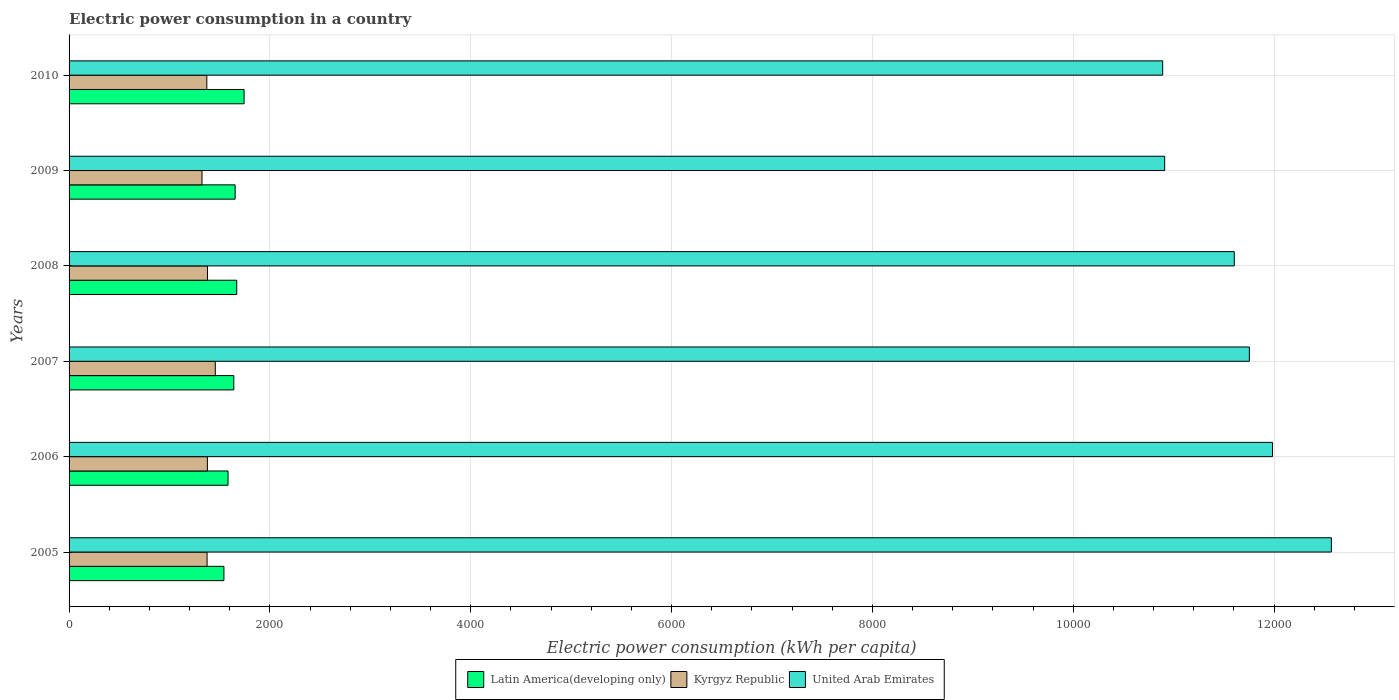How many different coloured bars are there?
Offer a very short reply. 3. How many groups of bars are there?
Ensure brevity in your answer.  6. Are the number of bars per tick equal to the number of legend labels?
Provide a short and direct response. Yes. Are the number of bars on each tick of the Y-axis equal?
Give a very brief answer. Yes. How many bars are there on the 2nd tick from the bottom?
Ensure brevity in your answer.  3. In how many cases, is the number of bars for a given year not equal to the number of legend labels?
Provide a short and direct response. 0. What is the electric power consumption in in Latin America(developing only) in 2009?
Keep it short and to the point. 1654.08. Across all years, what is the maximum electric power consumption in in United Arab Emirates?
Offer a terse response. 1.26e+04. Across all years, what is the minimum electric power consumption in in Latin America(developing only)?
Your answer should be compact. 1542.13. In which year was the electric power consumption in in United Arab Emirates maximum?
Your response must be concise. 2005. In which year was the electric power consumption in in Latin America(developing only) minimum?
Offer a terse response. 2005. What is the total electric power consumption in in United Arab Emirates in the graph?
Give a very brief answer. 6.97e+04. What is the difference between the electric power consumption in in United Arab Emirates in 2007 and that in 2009?
Your answer should be compact. 843.49. What is the difference between the electric power consumption in in United Arab Emirates in 2005 and the electric power consumption in in Latin America(developing only) in 2009?
Your answer should be very brief. 1.09e+04. What is the average electric power consumption in in Latin America(developing only) per year?
Your answer should be very brief. 1638.79. In the year 2009, what is the difference between the electric power consumption in in Latin America(developing only) and electric power consumption in in Kyrgyz Republic?
Your answer should be compact. 330.35. What is the ratio of the electric power consumption in in Kyrgyz Republic in 2007 to that in 2010?
Your response must be concise. 1.06. What is the difference between the highest and the second highest electric power consumption in in Latin America(developing only)?
Provide a short and direct response. 73.18. What is the difference between the highest and the lowest electric power consumption in in Latin America(developing only)?
Your answer should be compact. 200.81. Is the sum of the electric power consumption in in United Arab Emirates in 2008 and 2010 greater than the maximum electric power consumption in in Latin America(developing only) across all years?
Give a very brief answer. Yes. What does the 2nd bar from the top in 2007 represents?
Your answer should be compact. Kyrgyz Republic. What does the 3rd bar from the bottom in 2010 represents?
Give a very brief answer. United Arab Emirates. Is it the case that in every year, the sum of the electric power consumption in in United Arab Emirates and electric power consumption in in Latin America(developing only) is greater than the electric power consumption in in Kyrgyz Republic?
Your response must be concise. Yes. How many years are there in the graph?
Your response must be concise. 6. Are the values on the major ticks of X-axis written in scientific E-notation?
Ensure brevity in your answer.  No. Does the graph contain any zero values?
Your response must be concise. No. What is the title of the graph?
Make the answer very short. Electric power consumption in a country. What is the label or title of the X-axis?
Provide a short and direct response. Electric power consumption (kWh per capita). What is the label or title of the Y-axis?
Give a very brief answer. Years. What is the Electric power consumption (kWh per capita) in Latin America(developing only) in 2005?
Give a very brief answer. 1542.13. What is the Electric power consumption (kWh per capita) of Kyrgyz Republic in 2005?
Your answer should be compact. 1374.31. What is the Electric power consumption (kWh per capita) in United Arab Emirates in 2005?
Your answer should be very brief. 1.26e+04. What is the Electric power consumption (kWh per capita) in Latin America(developing only) in 2006?
Make the answer very short. 1583.23. What is the Electric power consumption (kWh per capita) in Kyrgyz Republic in 2006?
Your answer should be very brief. 1377.43. What is the Electric power consumption (kWh per capita) in United Arab Emirates in 2006?
Offer a terse response. 1.20e+04. What is the Electric power consumption (kWh per capita) of Latin America(developing only) in 2007?
Your answer should be compact. 1640.63. What is the Electric power consumption (kWh per capita) in Kyrgyz Republic in 2007?
Your answer should be very brief. 1456.23. What is the Electric power consumption (kWh per capita) in United Arab Emirates in 2007?
Make the answer very short. 1.18e+04. What is the Electric power consumption (kWh per capita) of Latin America(developing only) in 2008?
Give a very brief answer. 1669.76. What is the Electric power consumption (kWh per capita) of Kyrgyz Republic in 2008?
Ensure brevity in your answer.  1378.72. What is the Electric power consumption (kWh per capita) of United Arab Emirates in 2008?
Ensure brevity in your answer.  1.16e+04. What is the Electric power consumption (kWh per capita) of Latin America(developing only) in 2009?
Provide a short and direct response. 1654.08. What is the Electric power consumption (kWh per capita) of Kyrgyz Republic in 2009?
Make the answer very short. 1323.72. What is the Electric power consumption (kWh per capita) in United Arab Emirates in 2009?
Ensure brevity in your answer.  1.09e+04. What is the Electric power consumption (kWh per capita) of Latin America(developing only) in 2010?
Offer a terse response. 1742.94. What is the Electric power consumption (kWh per capita) in Kyrgyz Republic in 2010?
Your response must be concise. 1371.72. What is the Electric power consumption (kWh per capita) of United Arab Emirates in 2010?
Keep it short and to the point. 1.09e+04. Across all years, what is the maximum Electric power consumption (kWh per capita) in Latin America(developing only)?
Give a very brief answer. 1742.94. Across all years, what is the maximum Electric power consumption (kWh per capita) in Kyrgyz Republic?
Make the answer very short. 1456.23. Across all years, what is the maximum Electric power consumption (kWh per capita) of United Arab Emirates?
Ensure brevity in your answer.  1.26e+04. Across all years, what is the minimum Electric power consumption (kWh per capita) in Latin America(developing only)?
Ensure brevity in your answer.  1542.13. Across all years, what is the minimum Electric power consumption (kWh per capita) of Kyrgyz Republic?
Give a very brief answer. 1323.72. Across all years, what is the minimum Electric power consumption (kWh per capita) in United Arab Emirates?
Ensure brevity in your answer.  1.09e+04. What is the total Electric power consumption (kWh per capita) of Latin America(developing only) in the graph?
Your answer should be compact. 9832.77. What is the total Electric power consumption (kWh per capita) in Kyrgyz Republic in the graph?
Your response must be concise. 8282.14. What is the total Electric power consumption (kWh per capita) of United Arab Emirates in the graph?
Keep it short and to the point. 6.97e+04. What is the difference between the Electric power consumption (kWh per capita) of Latin America(developing only) in 2005 and that in 2006?
Offer a very short reply. -41.1. What is the difference between the Electric power consumption (kWh per capita) of Kyrgyz Republic in 2005 and that in 2006?
Offer a terse response. -3.13. What is the difference between the Electric power consumption (kWh per capita) of United Arab Emirates in 2005 and that in 2006?
Your answer should be very brief. 586.11. What is the difference between the Electric power consumption (kWh per capita) of Latin America(developing only) in 2005 and that in 2007?
Make the answer very short. -98.51. What is the difference between the Electric power consumption (kWh per capita) of Kyrgyz Republic in 2005 and that in 2007?
Make the answer very short. -81.92. What is the difference between the Electric power consumption (kWh per capita) of United Arab Emirates in 2005 and that in 2007?
Your response must be concise. 816.64. What is the difference between the Electric power consumption (kWh per capita) in Latin America(developing only) in 2005 and that in 2008?
Your answer should be compact. -127.63. What is the difference between the Electric power consumption (kWh per capita) of Kyrgyz Republic in 2005 and that in 2008?
Provide a succinct answer. -4.41. What is the difference between the Electric power consumption (kWh per capita) of United Arab Emirates in 2005 and that in 2008?
Make the answer very short. 966.91. What is the difference between the Electric power consumption (kWh per capita) of Latin America(developing only) in 2005 and that in 2009?
Your answer should be very brief. -111.95. What is the difference between the Electric power consumption (kWh per capita) of Kyrgyz Republic in 2005 and that in 2009?
Offer a terse response. 50.58. What is the difference between the Electric power consumption (kWh per capita) of United Arab Emirates in 2005 and that in 2009?
Keep it short and to the point. 1660.13. What is the difference between the Electric power consumption (kWh per capita) of Latin America(developing only) in 2005 and that in 2010?
Provide a short and direct response. -200.81. What is the difference between the Electric power consumption (kWh per capita) in Kyrgyz Republic in 2005 and that in 2010?
Provide a succinct answer. 2.59. What is the difference between the Electric power consumption (kWh per capita) of United Arab Emirates in 2005 and that in 2010?
Offer a terse response. 1680.15. What is the difference between the Electric power consumption (kWh per capita) of Latin America(developing only) in 2006 and that in 2007?
Your answer should be compact. -57.41. What is the difference between the Electric power consumption (kWh per capita) of Kyrgyz Republic in 2006 and that in 2007?
Your response must be concise. -78.8. What is the difference between the Electric power consumption (kWh per capita) of United Arab Emirates in 2006 and that in 2007?
Provide a succinct answer. 230.52. What is the difference between the Electric power consumption (kWh per capita) of Latin America(developing only) in 2006 and that in 2008?
Offer a very short reply. -86.53. What is the difference between the Electric power consumption (kWh per capita) in Kyrgyz Republic in 2006 and that in 2008?
Keep it short and to the point. -1.29. What is the difference between the Electric power consumption (kWh per capita) in United Arab Emirates in 2006 and that in 2008?
Ensure brevity in your answer.  380.8. What is the difference between the Electric power consumption (kWh per capita) of Latin America(developing only) in 2006 and that in 2009?
Give a very brief answer. -70.85. What is the difference between the Electric power consumption (kWh per capita) in Kyrgyz Republic in 2006 and that in 2009?
Provide a succinct answer. 53.71. What is the difference between the Electric power consumption (kWh per capita) of United Arab Emirates in 2006 and that in 2009?
Offer a very short reply. 1074.02. What is the difference between the Electric power consumption (kWh per capita) of Latin America(developing only) in 2006 and that in 2010?
Provide a short and direct response. -159.72. What is the difference between the Electric power consumption (kWh per capita) in Kyrgyz Republic in 2006 and that in 2010?
Provide a succinct answer. 5.71. What is the difference between the Electric power consumption (kWh per capita) in United Arab Emirates in 2006 and that in 2010?
Provide a succinct answer. 1094.03. What is the difference between the Electric power consumption (kWh per capita) in Latin America(developing only) in 2007 and that in 2008?
Provide a short and direct response. -29.12. What is the difference between the Electric power consumption (kWh per capita) of Kyrgyz Republic in 2007 and that in 2008?
Offer a terse response. 77.51. What is the difference between the Electric power consumption (kWh per capita) in United Arab Emirates in 2007 and that in 2008?
Offer a terse response. 150.27. What is the difference between the Electric power consumption (kWh per capita) in Latin America(developing only) in 2007 and that in 2009?
Offer a very short reply. -13.44. What is the difference between the Electric power consumption (kWh per capita) of Kyrgyz Republic in 2007 and that in 2009?
Keep it short and to the point. 132.51. What is the difference between the Electric power consumption (kWh per capita) of United Arab Emirates in 2007 and that in 2009?
Offer a very short reply. 843.49. What is the difference between the Electric power consumption (kWh per capita) of Latin America(developing only) in 2007 and that in 2010?
Keep it short and to the point. -102.31. What is the difference between the Electric power consumption (kWh per capita) of Kyrgyz Republic in 2007 and that in 2010?
Your answer should be very brief. 84.51. What is the difference between the Electric power consumption (kWh per capita) in United Arab Emirates in 2007 and that in 2010?
Ensure brevity in your answer.  863.51. What is the difference between the Electric power consumption (kWh per capita) in Latin America(developing only) in 2008 and that in 2009?
Keep it short and to the point. 15.68. What is the difference between the Electric power consumption (kWh per capita) in Kyrgyz Republic in 2008 and that in 2009?
Provide a short and direct response. 55. What is the difference between the Electric power consumption (kWh per capita) in United Arab Emirates in 2008 and that in 2009?
Provide a succinct answer. 693.22. What is the difference between the Electric power consumption (kWh per capita) of Latin America(developing only) in 2008 and that in 2010?
Provide a short and direct response. -73.18. What is the difference between the Electric power consumption (kWh per capita) in Kyrgyz Republic in 2008 and that in 2010?
Offer a terse response. 7. What is the difference between the Electric power consumption (kWh per capita) of United Arab Emirates in 2008 and that in 2010?
Your response must be concise. 713.24. What is the difference between the Electric power consumption (kWh per capita) of Latin America(developing only) in 2009 and that in 2010?
Keep it short and to the point. -88.87. What is the difference between the Electric power consumption (kWh per capita) of Kyrgyz Republic in 2009 and that in 2010?
Provide a succinct answer. -48. What is the difference between the Electric power consumption (kWh per capita) in United Arab Emirates in 2009 and that in 2010?
Give a very brief answer. 20.02. What is the difference between the Electric power consumption (kWh per capita) in Latin America(developing only) in 2005 and the Electric power consumption (kWh per capita) in Kyrgyz Republic in 2006?
Your answer should be very brief. 164.7. What is the difference between the Electric power consumption (kWh per capita) of Latin America(developing only) in 2005 and the Electric power consumption (kWh per capita) of United Arab Emirates in 2006?
Ensure brevity in your answer.  -1.04e+04. What is the difference between the Electric power consumption (kWh per capita) of Kyrgyz Republic in 2005 and the Electric power consumption (kWh per capita) of United Arab Emirates in 2006?
Your answer should be very brief. -1.06e+04. What is the difference between the Electric power consumption (kWh per capita) of Latin America(developing only) in 2005 and the Electric power consumption (kWh per capita) of Kyrgyz Republic in 2007?
Your answer should be compact. 85.9. What is the difference between the Electric power consumption (kWh per capita) of Latin America(developing only) in 2005 and the Electric power consumption (kWh per capita) of United Arab Emirates in 2007?
Offer a terse response. -1.02e+04. What is the difference between the Electric power consumption (kWh per capita) of Kyrgyz Republic in 2005 and the Electric power consumption (kWh per capita) of United Arab Emirates in 2007?
Your answer should be very brief. -1.04e+04. What is the difference between the Electric power consumption (kWh per capita) of Latin America(developing only) in 2005 and the Electric power consumption (kWh per capita) of Kyrgyz Republic in 2008?
Offer a terse response. 163.41. What is the difference between the Electric power consumption (kWh per capita) in Latin America(developing only) in 2005 and the Electric power consumption (kWh per capita) in United Arab Emirates in 2008?
Your response must be concise. -1.01e+04. What is the difference between the Electric power consumption (kWh per capita) of Kyrgyz Republic in 2005 and the Electric power consumption (kWh per capita) of United Arab Emirates in 2008?
Provide a succinct answer. -1.02e+04. What is the difference between the Electric power consumption (kWh per capita) in Latin America(developing only) in 2005 and the Electric power consumption (kWh per capita) in Kyrgyz Republic in 2009?
Keep it short and to the point. 218.41. What is the difference between the Electric power consumption (kWh per capita) in Latin America(developing only) in 2005 and the Electric power consumption (kWh per capita) in United Arab Emirates in 2009?
Offer a very short reply. -9368.76. What is the difference between the Electric power consumption (kWh per capita) in Kyrgyz Republic in 2005 and the Electric power consumption (kWh per capita) in United Arab Emirates in 2009?
Your answer should be compact. -9536.58. What is the difference between the Electric power consumption (kWh per capita) of Latin America(developing only) in 2005 and the Electric power consumption (kWh per capita) of Kyrgyz Republic in 2010?
Provide a succinct answer. 170.41. What is the difference between the Electric power consumption (kWh per capita) of Latin America(developing only) in 2005 and the Electric power consumption (kWh per capita) of United Arab Emirates in 2010?
Keep it short and to the point. -9348.74. What is the difference between the Electric power consumption (kWh per capita) in Kyrgyz Republic in 2005 and the Electric power consumption (kWh per capita) in United Arab Emirates in 2010?
Your answer should be compact. -9516.56. What is the difference between the Electric power consumption (kWh per capita) in Latin America(developing only) in 2006 and the Electric power consumption (kWh per capita) in Kyrgyz Republic in 2007?
Your answer should be compact. 127. What is the difference between the Electric power consumption (kWh per capita) of Latin America(developing only) in 2006 and the Electric power consumption (kWh per capita) of United Arab Emirates in 2007?
Give a very brief answer. -1.02e+04. What is the difference between the Electric power consumption (kWh per capita) of Kyrgyz Republic in 2006 and the Electric power consumption (kWh per capita) of United Arab Emirates in 2007?
Make the answer very short. -1.04e+04. What is the difference between the Electric power consumption (kWh per capita) in Latin America(developing only) in 2006 and the Electric power consumption (kWh per capita) in Kyrgyz Republic in 2008?
Keep it short and to the point. 204.51. What is the difference between the Electric power consumption (kWh per capita) in Latin America(developing only) in 2006 and the Electric power consumption (kWh per capita) in United Arab Emirates in 2008?
Offer a terse response. -1.00e+04. What is the difference between the Electric power consumption (kWh per capita) of Kyrgyz Republic in 2006 and the Electric power consumption (kWh per capita) of United Arab Emirates in 2008?
Make the answer very short. -1.02e+04. What is the difference between the Electric power consumption (kWh per capita) in Latin America(developing only) in 2006 and the Electric power consumption (kWh per capita) in Kyrgyz Republic in 2009?
Provide a succinct answer. 259.5. What is the difference between the Electric power consumption (kWh per capita) of Latin America(developing only) in 2006 and the Electric power consumption (kWh per capita) of United Arab Emirates in 2009?
Provide a short and direct response. -9327.66. What is the difference between the Electric power consumption (kWh per capita) in Kyrgyz Republic in 2006 and the Electric power consumption (kWh per capita) in United Arab Emirates in 2009?
Make the answer very short. -9533.45. What is the difference between the Electric power consumption (kWh per capita) in Latin America(developing only) in 2006 and the Electric power consumption (kWh per capita) in Kyrgyz Republic in 2010?
Your response must be concise. 211.51. What is the difference between the Electric power consumption (kWh per capita) of Latin America(developing only) in 2006 and the Electric power consumption (kWh per capita) of United Arab Emirates in 2010?
Make the answer very short. -9307.65. What is the difference between the Electric power consumption (kWh per capita) in Kyrgyz Republic in 2006 and the Electric power consumption (kWh per capita) in United Arab Emirates in 2010?
Make the answer very short. -9513.44. What is the difference between the Electric power consumption (kWh per capita) of Latin America(developing only) in 2007 and the Electric power consumption (kWh per capita) of Kyrgyz Republic in 2008?
Ensure brevity in your answer.  261.91. What is the difference between the Electric power consumption (kWh per capita) in Latin America(developing only) in 2007 and the Electric power consumption (kWh per capita) in United Arab Emirates in 2008?
Offer a very short reply. -9963.47. What is the difference between the Electric power consumption (kWh per capita) of Kyrgyz Republic in 2007 and the Electric power consumption (kWh per capita) of United Arab Emirates in 2008?
Ensure brevity in your answer.  -1.01e+04. What is the difference between the Electric power consumption (kWh per capita) of Latin America(developing only) in 2007 and the Electric power consumption (kWh per capita) of Kyrgyz Republic in 2009?
Provide a short and direct response. 316.91. What is the difference between the Electric power consumption (kWh per capita) in Latin America(developing only) in 2007 and the Electric power consumption (kWh per capita) in United Arab Emirates in 2009?
Offer a terse response. -9270.25. What is the difference between the Electric power consumption (kWh per capita) in Kyrgyz Republic in 2007 and the Electric power consumption (kWh per capita) in United Arab Emirates in 2009?
Ensure brevity in your answer.  -9454.66. What is the difference between the Electric power consumption (kWh per capita) in Latin America(developing only) in 2007 and the Electric power consumption (kWh per capita) in Kyrgyz Republic in 2010?
Keep it short and to the point. 268.91. What is the difference between the Electric power consumption (kWh per capita) of Latin America(developing only) in 2007 and the Electric power consumption (kWh per capita) of United Arab Emirates in 2010?
Make the answer very short. -9250.24. What is the difference between the Electric power consumption (kWh per capita) in Kyrgyz Republic in 2007 and the Electric power consumption (kWh per capita) in United Arab Emirates in 2010?
Your response must be concise. -9434.64. What is the difference between the Electric power consumption (kWh per capita) of Latin America(developing only) in 2008 and the Electric power consumption (kWh per capita) of Kyrgyz Republic in 2009?
Keep it short and to the point. 346.04. What is the difference between the Electric power consumption (kWh per capita) in Latin America(developing only) in 2008 and the Electric power consumption (kWh per capita) in United Arab Emirates in 2009?
Ensure brevity in your answer.  -9241.13. What is the difference between the Electric power consumption (kWh per capita) in Kyrgyz Republic in 2008 and the Electric power consumption (kWh per capita) in United Arab Emirates in 2009?
Make the answer very short. -9532.17. What is the difference between the Electric power consumption (kWh per capita) of Latin America(developing only) in 2008 and the Electric power consumption (kWh per capita) of Kyrgyz Republic in 2010?
Offer a terse response. 298.04. What is the difference between the Electric power consumption (kWh per capita) in Latin America(developing only) in 2008 and the Electric power consumption (kWh per capita) in United Arab Emirates in 2010?
Make the answer very short. -9221.11. What is the difference between the Electric power consumption (kWh per capita) in Kyrgyz Republic in 2008 and the Electric power consumption (kWh per capita) in United Arab Emirates in 2010?
Give a very brief answer. -9512.15. What is the difference between the Electric power consumption (kWh per capita) in Latin America(developing only) in 2009 and the Electric power consumption (kWh per capita) in Kyrgyz Republic in 2010?
Give a very brief answer. 282.35. What is the difference between the Electric power consumption (kWh per capita) in Latin America(developing only) in 2009 and the Electric power consumption (kWh per capita) in United Arab Emirates in 2010?
Your response must be concise. -9236.8. What is the difference between the Electric power consumption (kWh per capita) of Kyrgyz Republic in 2009 and the Electric power consumption (kWh per capita) of United Arab Emirates in 2010?
Your answer should be compact. -9567.15. What is the average Electric power consumption (kWh per capita) in Latin America(developing only) per year?
Offer a very short reply. 1638.79. What is the average Electric power consumption (kWh per capita) of Kyrgyz Republic per year?
Provide a short and direct response. 1380.36. What is the average Electric power consumption (kWh per capita) in United Arab Emirates per year?
Offer a terse response. 1.16e+04. In the year 2005, what is the difference between the Electric power consumption (kWh per capita) in Latin America(developing only) and Electric power consumption (kWh per capita) in Kyrgyz Republic?
Provide a succinct answer. 167.82. In the year 2005, what is the difference between the Electric power consumption (kWh per capita) of Latin America(developing only) and Electric power consumption (kWh per capita) of United Arab Emirates?
Provide a succinct answer. -1.10e+04. In the year 2005, what is the difference between the Electric power consumption (kWh per capita) in Kyrgyz Republic and Electric power consumption (kWh per capita) in United Arab Emirates?
Make the answer very short. -1.12e+04. In the year 2006, what is the difference between the Electric power consumption (kWh per capita) in Latin America(developing only) and Electric power consumption (kWh per capita) in Kyrgyz Republic?
Provide a short and direct response. 205.79. In the year 2006, what is the difference between the Electric power consumption (kWh per capita) of Latin America(developing only) and Electric power consumption (kWh per capita) of United Arab Emirates?
Provide a succinct answer. -1.04e+04. In the year 2006, what is the difference between the Electric power consumption (kWh per capita) in Kyrgyz Republic and Electric power consumption (kWh per capita) in United Arab Emirates?
Provide a succinct answer. -1.06e+04. In the year 2007, what is the difference between the Electric power consumption (kWh per capita) of Latin America(developing only) and Electric power consumption (kWh per capita) of Kyrgyz Republic?
Offer a very short reply. 184.41. In the year 2007, what is the difference between the Electric power consumption (kWh per capita) in Latin America(developing only) and Electric power consumption (kWh per capita) in United Arab Emirates?
Your response must be concise. -1.01e+04. In the year 2007, what is the difference between the Electric power consumption (kWh per capita) in Kyrgyz Republic and Electric power consumption (kWh per capita) in United Arab Emirates?
Offer a very short reply. -1.03e+04. In the year 2008, what is the difference between the Electric power consumption (kWh per capita) in Latin America(developing only) and Electric power consumption (kWh per capita) in Kyrgyz Republic?
Ensure brevity in your answer.  291.04. In the year 2008, what is the difference between the Electric power consumption (kWh per capita) of Latin America(developing only) and Electric power consumption (kWh per capita) of United Arab Emirates?
Provide a short and direct response. -9934.35. In the year 2008, what is the difference between the Electric power consumption (kWh per capita) of Kyrgyz Republic and Electric power consumption (kWh per capita) of United Arab Emirates?
Your answer should be very brief. -1.02e+04. In the year 2009, what is the difference between the Electric power consumption (kWh per capita) in Latin America(developing only) and Electric power consumption (kWh per capita) in Kyrgyz Republic?
Make the answer very short. 330.35. In the year 2009, what is the difference between the Electric power consumption (kWh per capita) in Latin America(developing only) and Electric power consumption (kWh per capita) in United Arab Emirates?
Ensure brevity in your answer.  -9256.81. In the year 2009, what is the difference between the Electric power consumption (kWh per capita) in Kyrgyz Republic and Electric power consumption (kWh per capita) in United Arab Emirates?
Provide a short and direct response. -9587.16. In the year 2010, what is the difference between the Electric power consumption (kWh per capita) of Latin America(developing only) and Electric power consumption (kWh per capita) of Kyrgyz Republic?
Offer a terse response. 371.22. In the year 2010, what is the difference between the Electric power consumption (kWh per capita) of Latin America(developing only) and Electric power consumption (kWh per capita) of United Arab Emirates?
Make the answer very short. -9147.93. In the year 2010, what is the difference between the Electric power consumption (kWh per capita) in Kyrgyz Republic and Electric power consumption (kWh per capita) in United Arab Emirates?
Your answer should be very brief. -9519.15. What is the ratio of the Electric power consumption (kWh per capita) in Latin America(developing only) in 2005 to that in 2006?
Make the answer very short. 0.97. What is the ratio of the Electric power consumption (kWh per capita) in Kyrgyz Republic in 2005 to that in 2006?
Provide a succinct answer. 1. What is the ratio of the Electric power consumption (kWh per capita) in United Arab Emirates in 2005 to that in 2006?
Provide a succinct answer. 1.05. What is the ratio of the Electric power consumption (kWh per capita) in Latin America(developing only) in 2005 to that in 2007?
Ensure brevity in your answer.  0.94. What is the ratio of the Electric power consumption (kWh per capita) in Kyrgyz Republic in 2005 to that in 2007?
Your answer should be compact. 0.94. What is the ratio of the Electric power consumption (kWh per capita) in United Arab Emirates in 2005 to that in 2007?
Your answer should be very brief. 1.07. What is the ratio of the Electric power consumption (kWh per capita) of Latin America(developing only) in 2005 to that in 2008?
Offer a very short reply. 0.92. What is the ratio of the Electric power consumption (kWh per capita) of Latin America(developing only) in 2005 to that in 2009?
Provide a succinct answer. 0.93. What is the ratio of the Electric power consumption (kWh per capita) of Kyrgyz Republic in 2005 to that in 2009?
Provide a succinct answer. 1.04. What is the ratio of the Electric power consumption (kWh per capita) of United Arab Emirates in 2005 to that in 2009?
Provide a short and direct response. 1.15. What is the ratio of the Electric power consumption (kWh per capita) of Latin America(developing only) in 2005 to that in 2010?
Your answer should be very brief. 0.88. What is the ratio of the Electric power consumption (kWh per capita) in United Arab Emirates in 2005 to that in 2010?
Give a very brief answer. 1.15. What is the ratio of the Electric power consumption (kWh per capita) in Kyrgyz Republic in 2006 to that in 2007?
Give a very brief answer. 0.95. What is the ratio of the Electric power consumption (kWh per capita) in United Arab Emirates in 2006 to that in 2007?
Give a very brief answer. 1.02. What is the ratio of the Electric power consumption (kWh per capita) in Latin America(developing only) in 2006 to that in 2008?
Your answer should be compact. 0.95. What is the ratio of the Electric power consumption (kWh per capita) of United Arab Emirates in 2006 to that in 2008?
Your response must be concise. 1.03. What is the ratio of the Electric power consumption (kWh per capita) in Latin America(developing only) in 2006 to that in 2009?
Keep it short and to the point. 0.96. What is the ratio of the Electric power consumption (kWh per capita) in Kyrgyz Republic in 2006 to that in 2009?
Give a very brief answer. 1.04. What is the ratio of the Electric power consumption (kWh per capita) in United Arab Emirates in 2006 to that in 2009?
Offer a terse response. 1.1. What is the ratio of the Electric power consumption (kWh per capita) of Latin America(developing only) in 2006 to that in 2010?
Your answer should be very brief. 0.91. What is the ratio of the Electric power consumption (kWh per capita) in United Arab Emirates in 2006 to that in 2010?
Your answer should be compact. 1.1. What is the ratio of the Electric power consumption (kWh per capita) in Latin America(developing only) in 2007 to that in 2008?
Offer a very short reply. 0.98. What is the ratio of the Electric power consumption (kWh per capita) in Kyrgyz Republic in 2007 to that in 2008?
Offer a terse response. 1.06. What is the ratio of the Electric power consumption (kWh per capita) in United Arab Emirates in 2007 to that in 2008?
Ensure brevity in your answer.  1.01. What is the ratio of the Electric power consumption (kWh per capita) of Kyrgyz Republic in 2007 to that in 2009?
Your answer should be compact. 1.1. What is the ratio of the Electric power consumption (kWh per capita) in United Arab Emirates in 2007 to that in 2009?
Offer a terse response. 1.08. What is the ratio of the Electric power consumption (kWh per capita) in Latin America(developing only) in 2007 to that in 2010?
Keep it short and to the point. 0.94. What is the ratio of the Electric power consumption (kWh per capita) of Kyrgyz Republic in 2007 to that in 2010?
Make the answer very short. 1.06. What is the ratio of the Electric power consumption (kWh per capita) of United Arab Emirates in 2007 to that in 2010?
Provide a short and direct response. 1.08. What is the ratio of the Electric power consumption (kWh per capita) in Latin America(developing only) in 2008 to that in 2009?
Ensure brevity in your answer.  1.01. What is the ratio of the Electric power consumption (kWh per capita) of Kyrgyz Republic in 2008 to that in 2009?
Offer a terse response. 1.04. What is the ratio of the Electric power consumption (kWh per capita) in United Arab Emirates in 2008 to that in 2009?
Your answer should be compact. 1.06. What is the ratio of the Electric power consumption (kWh per capita) in Latin America(developing only) in 2008 to that in 2010?
Keep it short and to the point. 0.96. What is the ratio of the Electric power consumption (kWh per capita) in Kyrgyz Republic in 2008 to that in 2010?
Offer a very short reply. 1.01. What is the ratio of the Electric power consumption (kWh per capita) of United Arab Emirates in 2008 to that in 2010?
Your answer should be very brief. 1.07. What is the ratio of the Electric power consumption (kWh per capita) of Latin America(developing only) in 2009 to that in 2010?
Your response must be concise. 0.95. What is the difference between the highest and the second highest Electric power consumption (kWh per capita) of Latin America(developing only)?
Make the answer very short. 73.18. What is the difference between the highest and the second highest Electric power consumption (kWh per capita) of Kyrgyz Republic?
Offer a terse response. 77.51. What is the difference between the highest and the second highest Electric power consumption (kWh per capita) in United Arab Emirates?
Provide a short and direct response. 586.11. What is the difference between the highest and the lowest Electric power consumption (kWh per capita) of Latin America(developing only)?
Provide a short and direct response. 200.81. What is the difference between the highest and the lowest Electric power consumption (kWh per capita) in Kyrgyz Republic?
Offer a terse response. 132.51. What is the difference between the highest and the lowest Electric power consumption (kWh per capita) of United Arab Emirates?
Offer a terse response. 1680.15. 